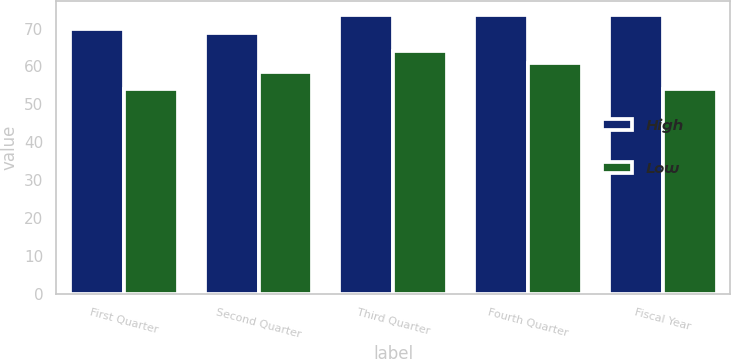Convert chart to OTSL. <chart><loc_0><loc_0><loc_500><loc_500><stacked_bar_chart><ecel><fcel>First Quarter<fcel>Second Quarter<fcel>Third Quarter<fcel>Fourth Quarter<fcel>Fiscal Year<nl><fcel>High<fcel>69.92<fcel>68.92<fcel>73.57<fcel>73.68<fcel>73.68<nl><fcel>Low<fcel>53.99<fcel>58.63<fcel>64.09<fcel>60.88<fcel>53.99<nl></chart> 